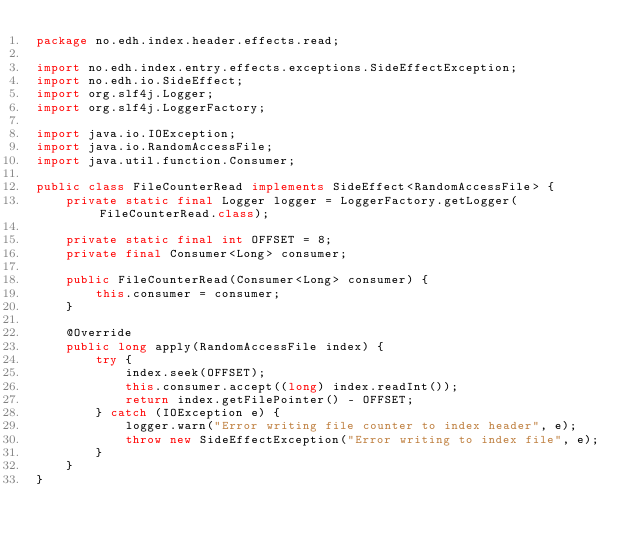Convert code to text. <code><loc_0><loc_0><loc_500><loc_500><_Java_>package no.edh.index.header.effects.read;

import no.edh.index.entry.effects.exceptions.SideEffectException;
import no.edh.io.SideEffect;
import org.slf4j.Logger;
import org.slf4j.LoggerFactory;

import java.io.IOException;
import java.io.RandomAccessFile;
import java.util.function.Consumer;

public class FileCounterRead implements SideEffect<RandomAccessFile> {
    private static final Logger logger = LoggerFactory.getLogger(FileCounterRead.class);

    private static final int OFFSET = 8;
    private final Consumer<Long> consumer;

    public FileCounterRead(Consumer<Long> consumer) {
        this.consumer = consumer;
    }

    @Override
    public long apply(RandomAccessFile index) {
        try {
            index.seek(OFFSET);
            this.consumer.accept((long) index.readInt());
            return index.getFilePointer() - OFFSET;
        } catch (IOException e) {
            logger.warn("Error writing file counter to index header", e);
            throw new SideEffectException("Error writing to index file", e);
        }
    }
}
</code> 